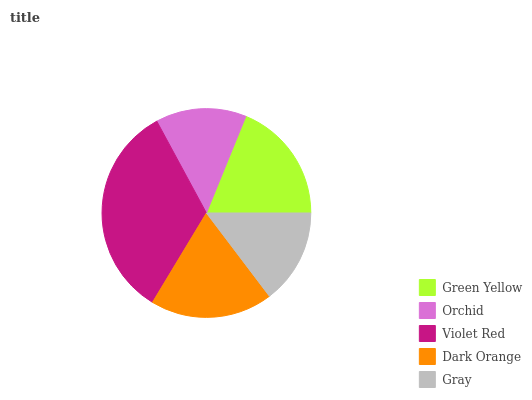Is Orchid the minimum?
Answer yes or no. Yes. Is Violet Red the maximum?
Answer yes or no. Yes. Is Violet Red the minimum?
Answer yes or no. No. Is Orchid the maximum?
Answer yes or no. No. Is Violet Red greater than Orchid?
Answer yes or no. Yes. Is Orchid less than Violet Red?
Answer yes or no. Yes. Is Orchid greater than Violet Red?
Answer yes or no. No. Is Violet Red less than Orchid?
Answer yes or no. No. Is Green Yellow the high median?
Answer yes or no. Yes. Is Green Yellow the low median?
Answer yes or no. Yes. Is Dark Orange the high median?
Answer yes or no. No. Is Orchid the low median?
Answer yes or no. No. 